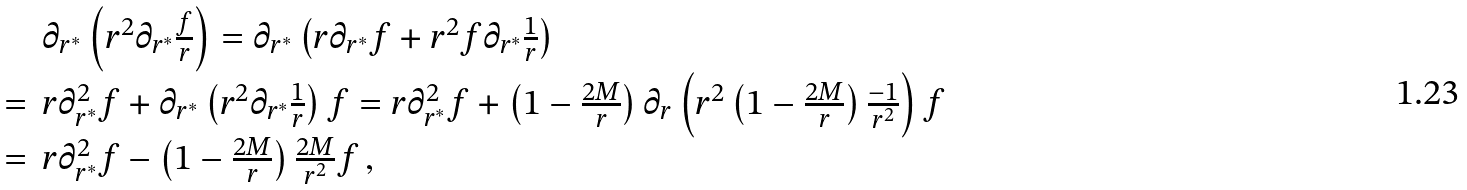<formula> <loc_0><loc_0><loc_500><loc_500>\begin{array} { l l } { \ } & { { \partial _ { r ^ { * } } \left ( r ^ { 2 } \partial _ { r ^ { * } } { \frac { f } { r } } \right ) = \partial _ { r ^ { * } } \left ( r \partial _ { r ^ { * } } f + r ^ { 2 } f \partial _ { r ^ { * } } { \frac { 1 } { r } } \right ) } } \\ { = } & { { r \partial _ { r ^ { * } } ^ { 2 } f + \partial _ { r ^ { * } } \left ( r ^ { 2 } \partial _ { r ^ { * } } { \frac { 1 } { r } } \right ) f = r \partial _ { r ^ { * } } ^ { 2 } f + \left ( 1 - { \frac { 2 M } { r } } \right ) \partial _ { r } \left ( r ^ { 2 } \left ( 1 - { \frac { 2 M } { r } } \right ) { \frac { - 1 } { r ^ { 2 } } } \right ) f } } \\ { = } & { { r \partial _ { r ^ { * } } ^ { 2 } f - \left ( 1 - { \frac { 2 M } { r } } \right ) { \frac { 2 M } { r ^ { 2 } } } f \, , } } \end{array}</formula> 